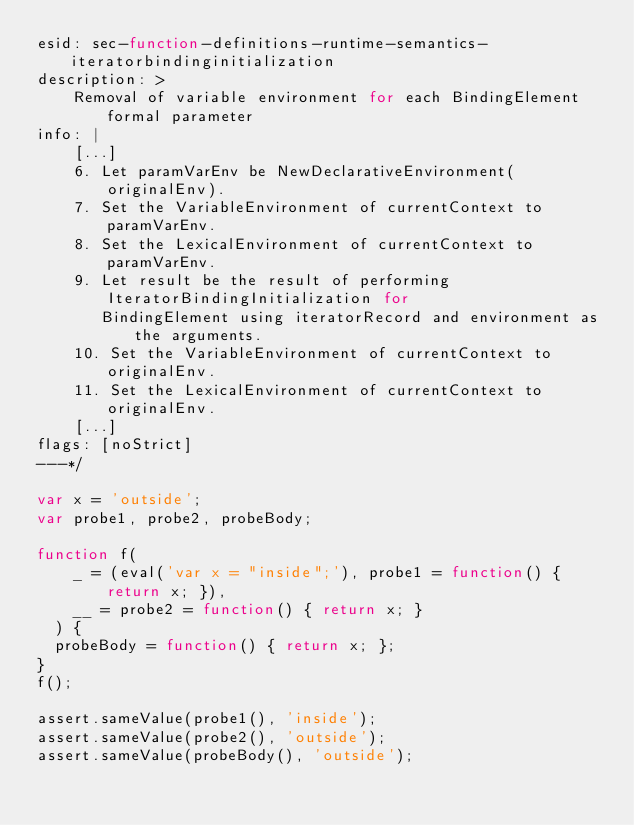<code> <loc_0><loc_0><loc_500><loc_500><_JavaScript_>esid: sec-function-definitions-runtime-semantics-iteratorbindinginitialization
description: >
    Removal of variable environment for each BindingElement formal parameter
info: |
    [...]
    6. Let paramVarEnv be NewDeclarativeEnvironment(originalEnv).
    7. Set the VariableEnvironment of currentContext to paramVarEnv.
    8. Set the LexicalEnvironment of currentContext to paramVarEnv.
    9. Let result be the result of performing IteratorBindingInitialization for
       BindingElement using iteratorRecord and environment as the arguments.
    10. Set the VariableEnvironment of currentContext to originalEnv.
    11. Set the LexicalEnvironment of currentContext to originalEnv.
    [...]
flags: [noStrict]
---*/

var x = 'outside';
var probe1, probe2, probeBody;

function f(
    _ = (eval('var x = "inside";'), probe1 = function() { return x; }),
    __ = probe2 = function() { return x; }
  ) {
  probeBody = function() { return x; };
}
f();

assert.sameValue(probe1(), 'inside');
assert.sameValue(probe2(), 'outside');
assert.sameValue(probeBody(), 'outside');
</code> 